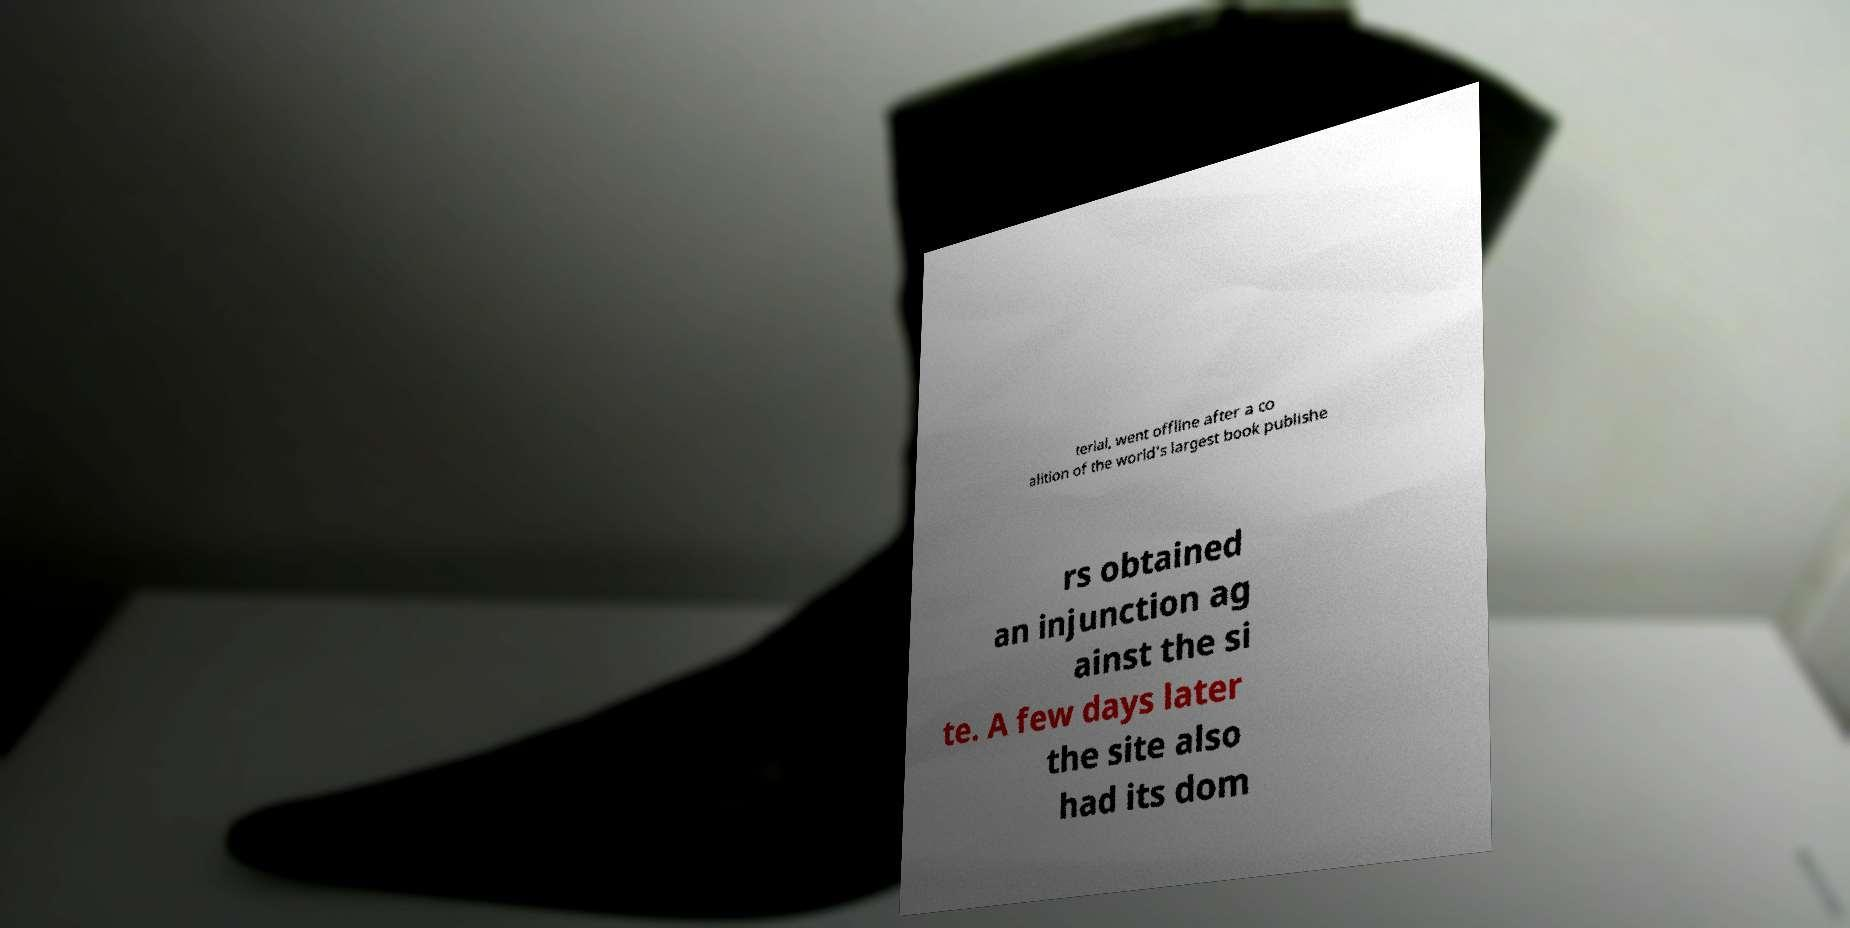For documentation purposes, I need the text within this image transcribed. Could you provide that? terial, went offline after a co alition of the world's largest book publishe rs obtained an injunction ag ainst the si te. A few days later the site also had its dom 